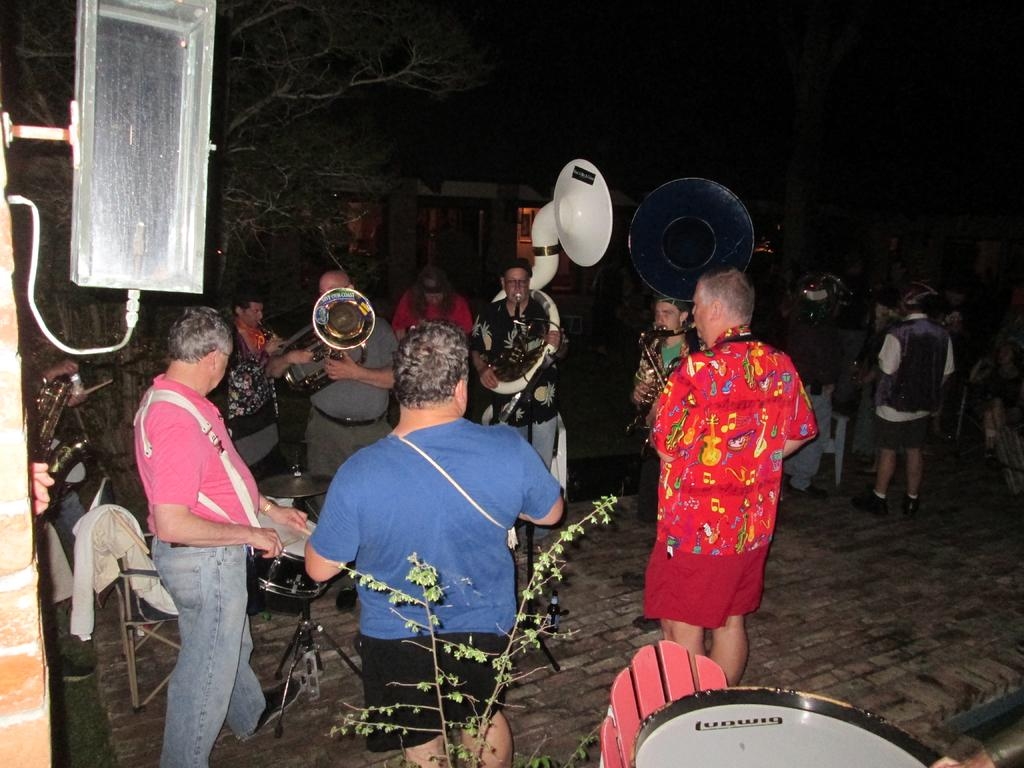How many people are in the image? There are people in the image, but the exact number is not specified. What are some of the people doing in the image? Some of the people are playing musical instruments. What type of natural element is present in the image? There is a tree in the image. What type of man-made structure is present in the image? There is a house in the image. How many nests can be seen in the image? There are no nests visible in the image. 